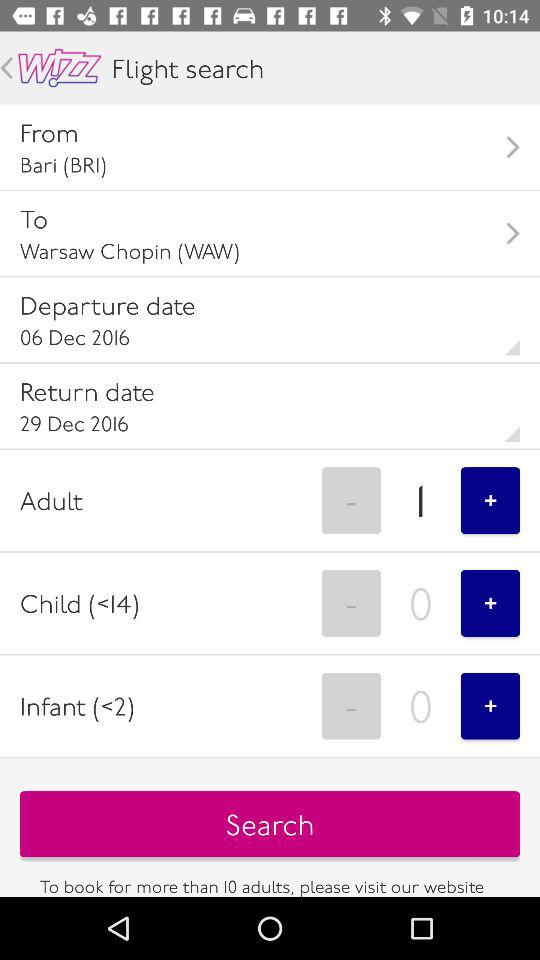What is the destination of the flight? The destination of the flight is Warsaw Chopin (WAW). 